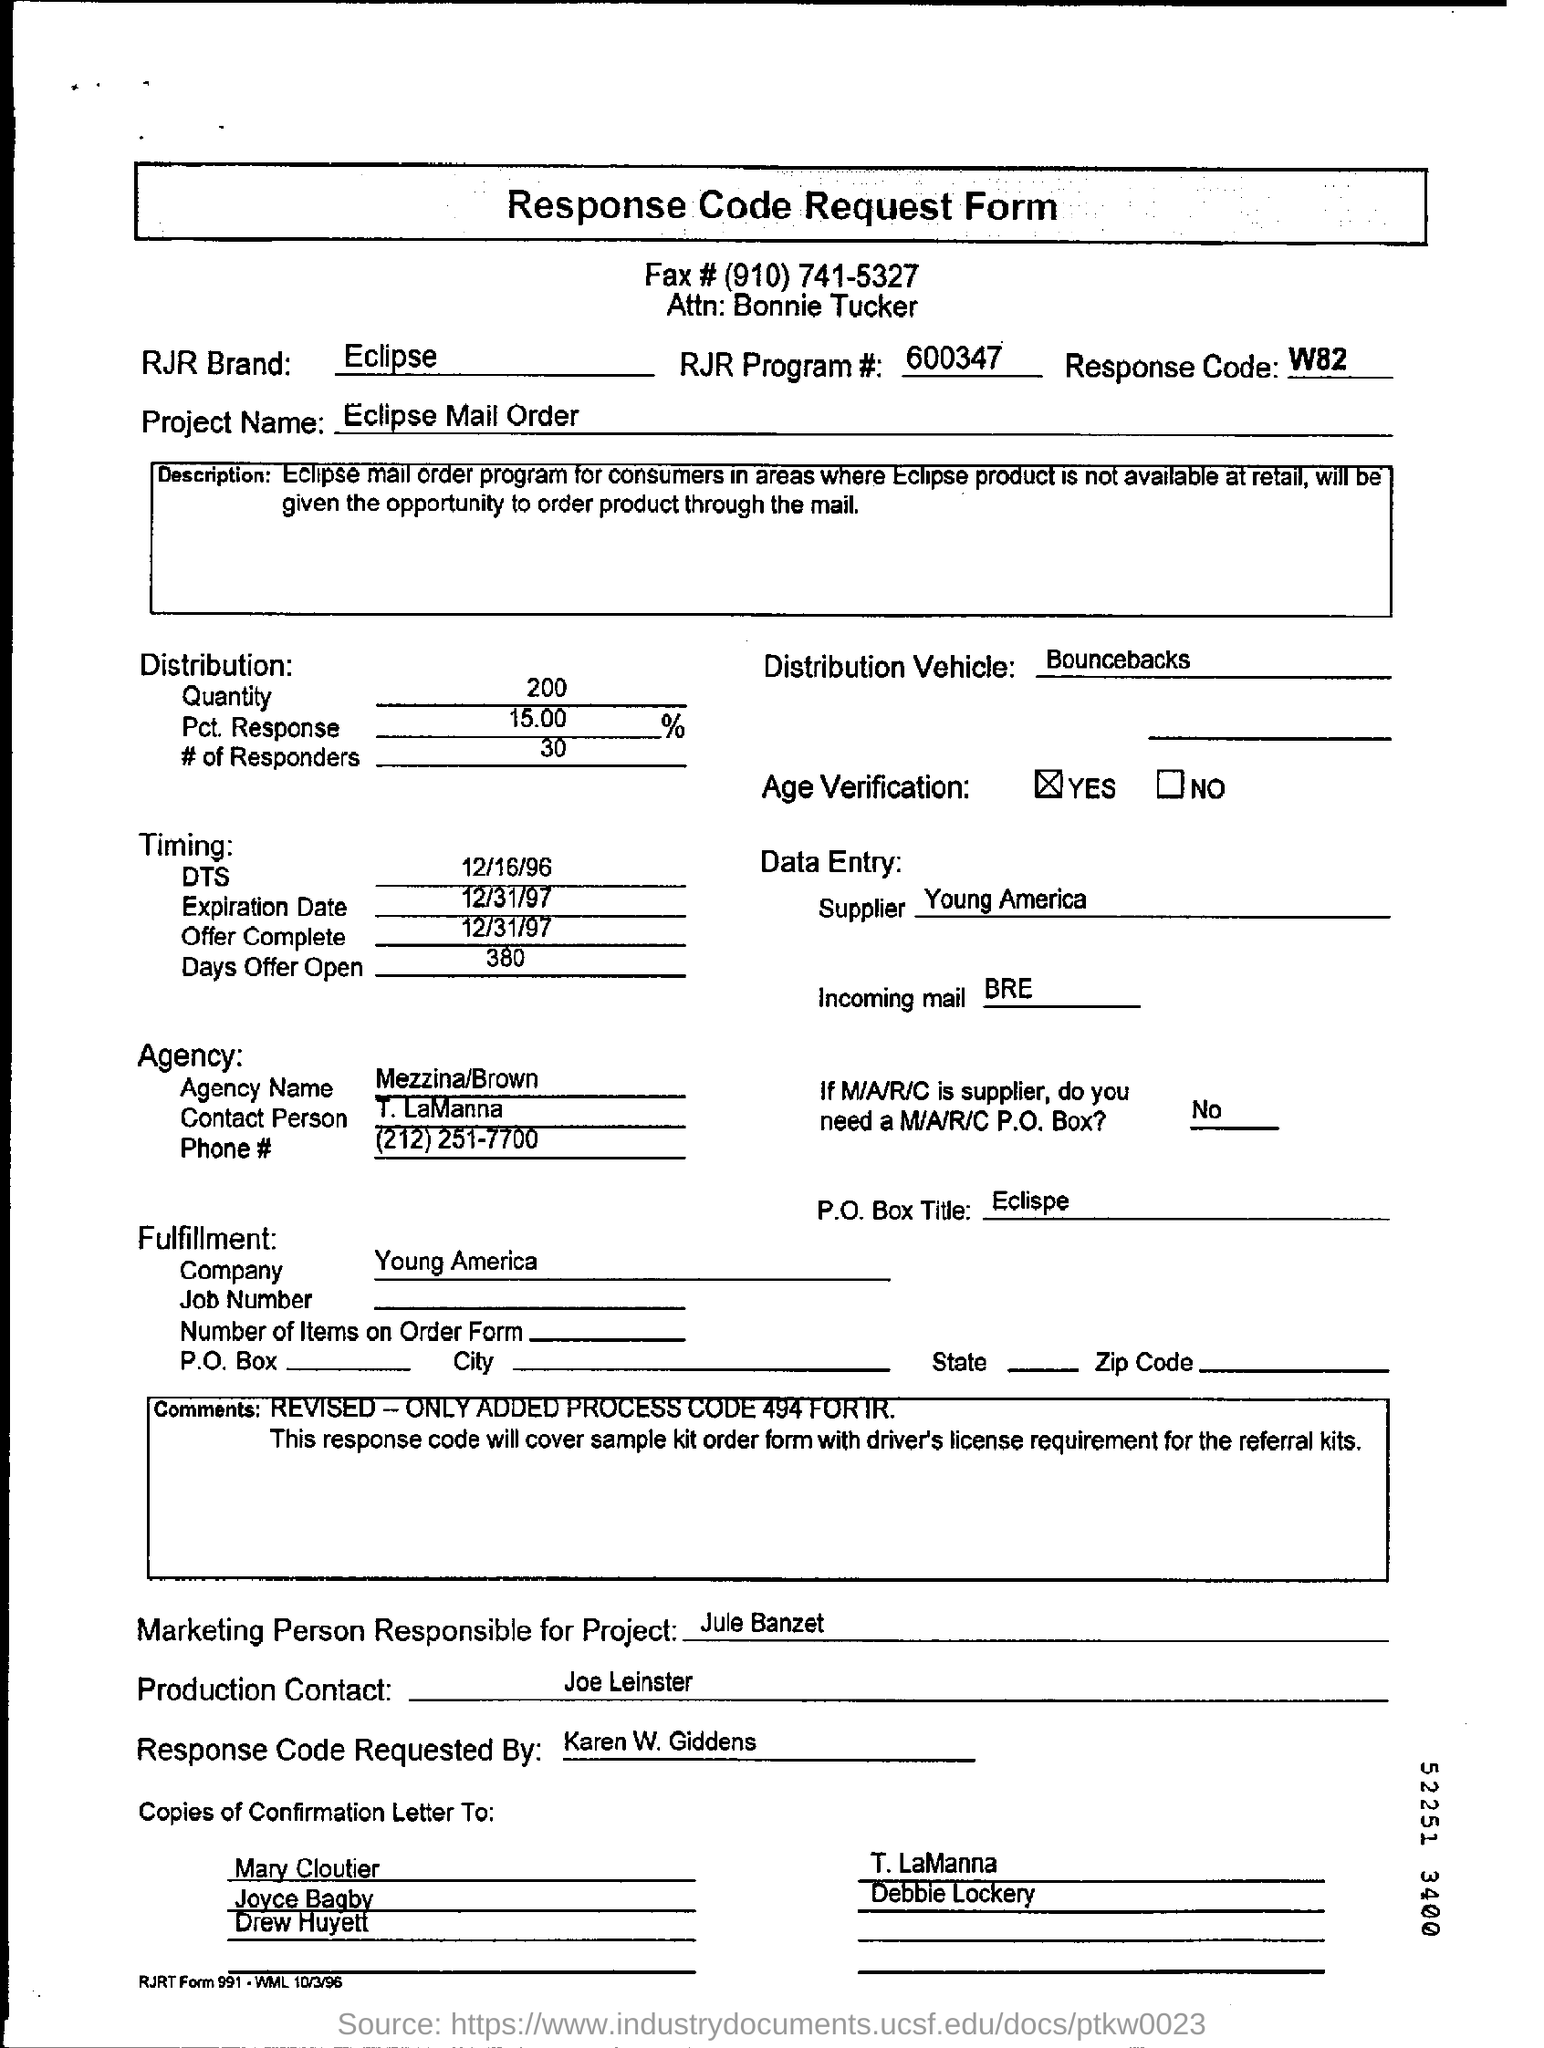What is the Project Name ?
Give a very brief answer. Eclipse Mail Order. What is Response Code ?
Ensure brevity in your answer.  W82. What is RJR program number ?
Your response must be concise. 600347. What is the name of the company ?
Your answer should be compact. Young America. What is the Quantity of the Distribution ?
Keep it short and to the point. 200. 